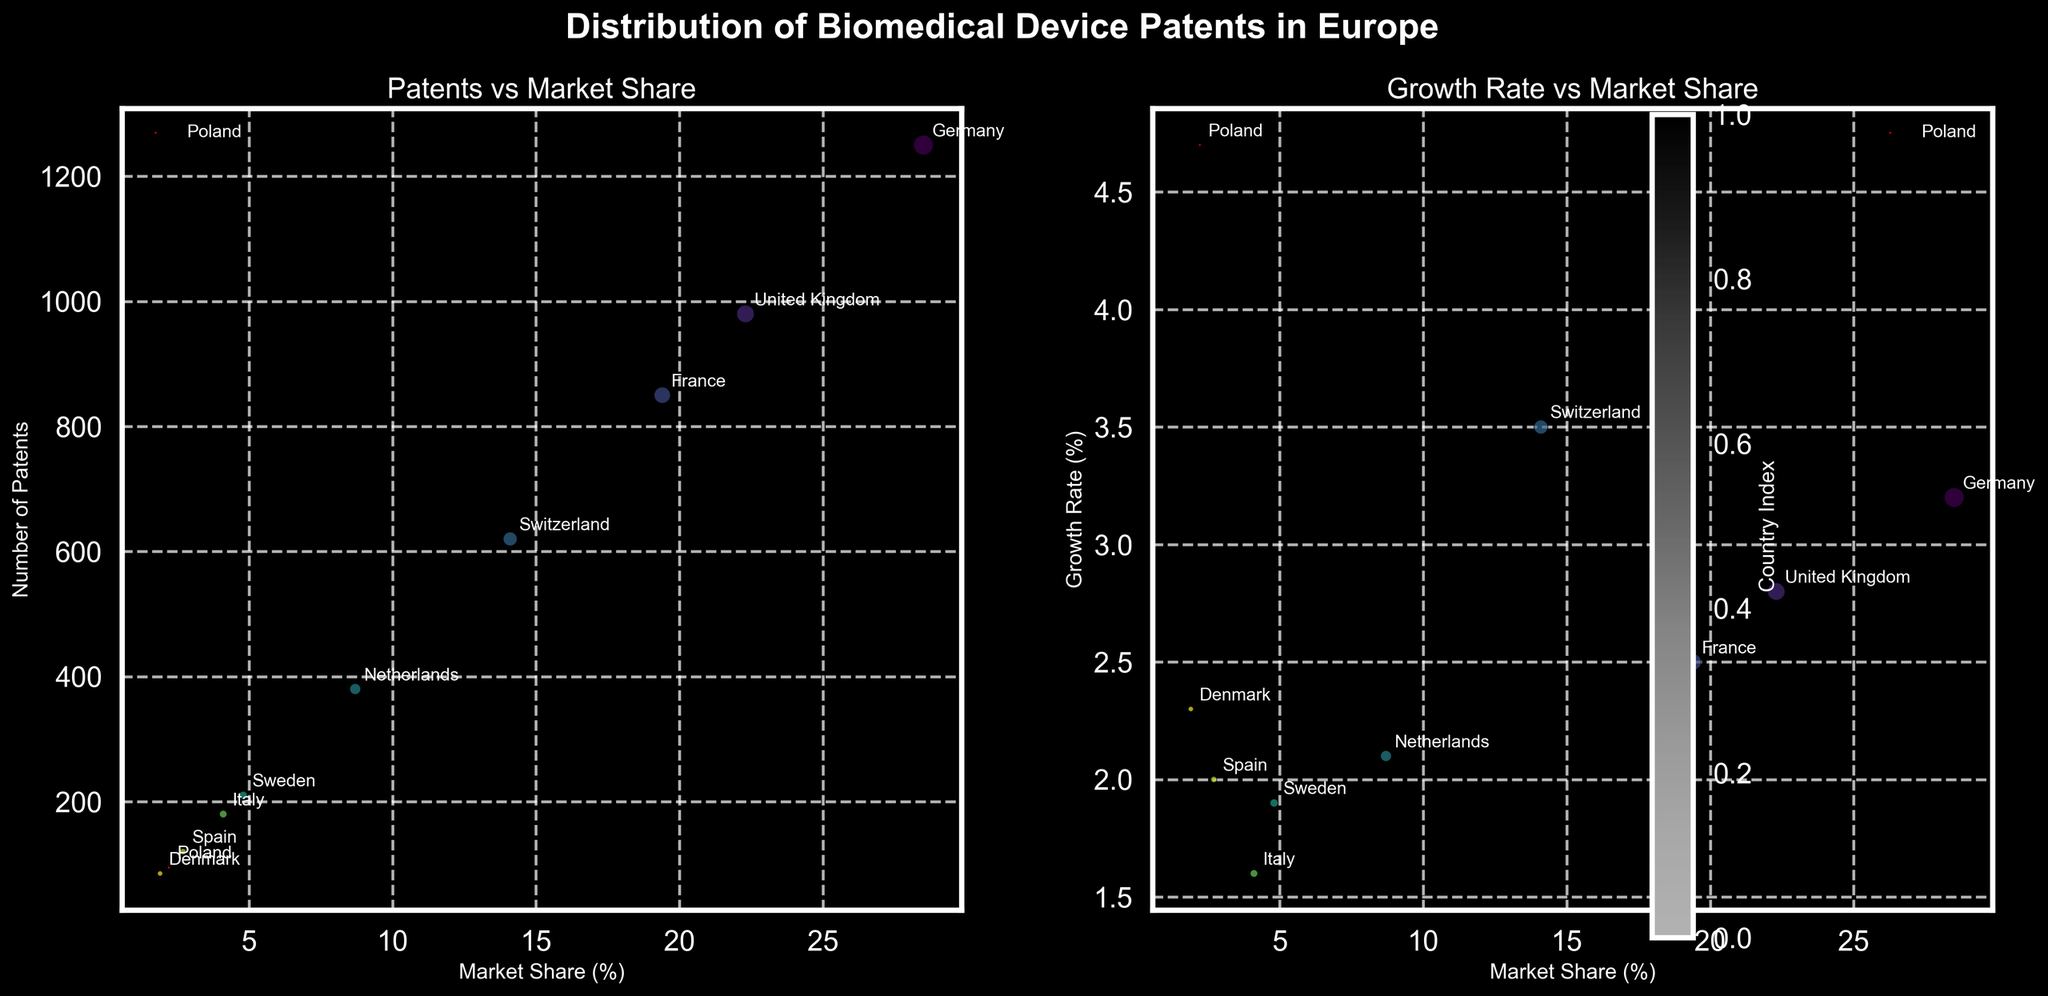How many European countries are represented in the chart? Both subplots show data points each labeled with a country's name. By counting these labels, we can determine the number of countries.
Answer: 10 Which country has the highest growth rate, and what is its growth rate? In the second subplot, the y-axis represents the growth rate. The highest data point on the y-axis, which is 4.7%, is labeled as Poland.
Answer: Poland, 4.7% What is the relationship between the number of patents and the market share for Germany? Look at the first subplot where the x-axis represents market share and the y-axis represents the number of patents. Find the data point labeled as Germany; it has around 28.5% market share and 1250 patents.
Answer: Germany has 1250 patents and a 28.5% market share Which country contributes the most patents and what is its market share? In the first subplot, the highest bubble on the y-axis represents the country with the most patents. This bubble is labeled as Germany; refer to the x-axis for its market share, which is around 28.5%.
Answer: Germany, 28.5% Does Poland have a higher or lower growth rate compared to the Netherlands? Look at the second subplot where the y-axis represents the growth rate. The point labeled Poland (4.7%) is higher than the point labeled Netherlands (2.1%).
Answer: Higher How many more patents does France have compared to Poland? In the first subplot, the y-axis represents the number of patents. The bubble labeled France is at 850, and the bubble for Poland is at 95. Subtract 95 from 850 to find the difference.
Answer: 755 Compare the market shares of the countries with the lowest and highest number of patents. In the first subplot, Germany has the highest number of patents (1250) with a market share of 28.5%. Denmark has the lowest number of patents (85) with a market share of 1.9%.
Answer: Germany: 28.5%, Denmark: 1.9% What is the sum of the market shares of Italy and Spain? In the first subplot, Italy has a market share of 4.1%, and Spain has a market share of 2.7%. Adding these together gives 4.1% + 2.7% = 6.8%.
Answer: 6.8% Which country has the smallest bubble in both charts, and what does this represent? The smallest bubble in both subplots corresponds to Denmark, indicating it has the fewest patents among the countries, which is 85.
Answer: Denmark, 85 patents 